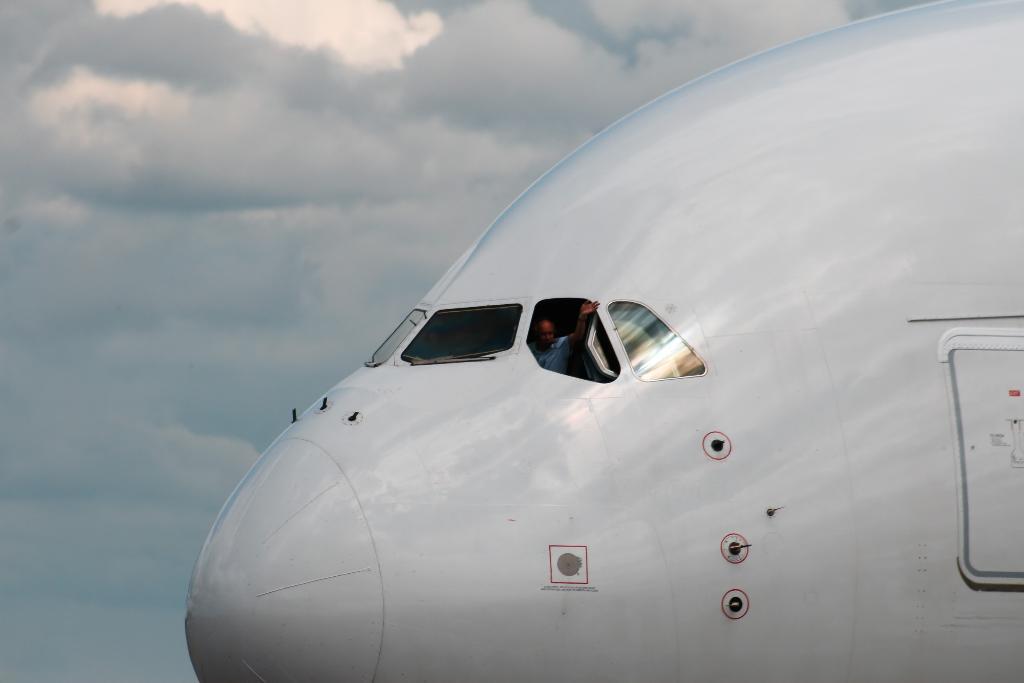Could you give a brief overview of what you see in this image? In this image we can see a front part of the airplane, inside the airplane there is a person sitting, in the background there is a sky with clouds. 